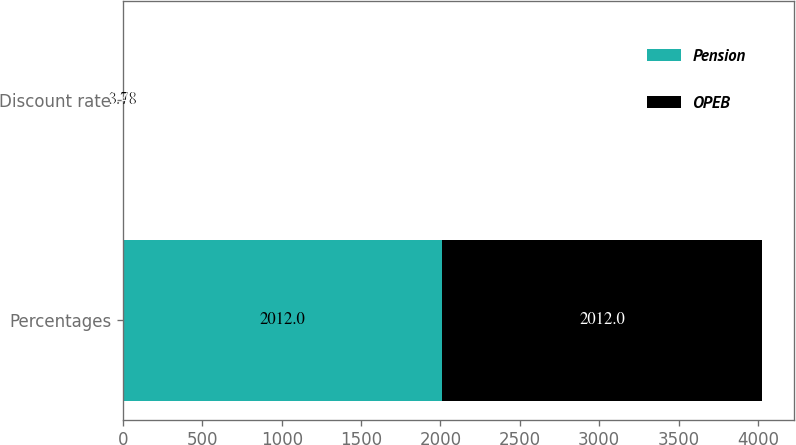Convert chart to OTSL. <chart><loc_0><loc_0><loc_500><loc_500><stacked_bar_chart><ecel><fcel>Percentages<fcel>Discount rate<nl><fcel>Pension<fcel>2012<fcel>3.78<nl><fcel>OPEB<fcel>2012<fcel>3.48<nl></chart> 